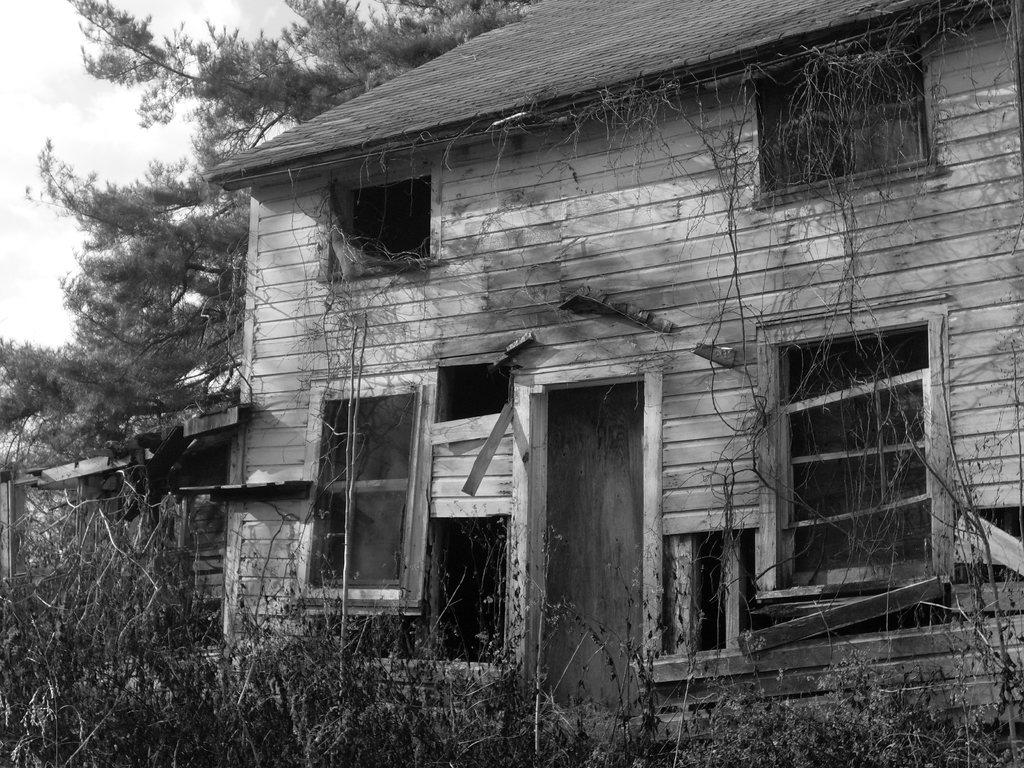What type of structure is in the image? There is a house in the image. What feature of the house is mentioned in the facts? The house has windows. What type of vegetation is present at the bottom of the image? There is grass at the bottom of the image. What other natural element is present in the image? There is a tree in the image. What type of prose can be seen on the tree in the image? There is no prose present on the tree in the image; it is a natural element with no text or writing. How does the view from the house compare to the view from the rake in the image? There is no rake present in the image, so it is not possible to compare views from the house and a rake. 